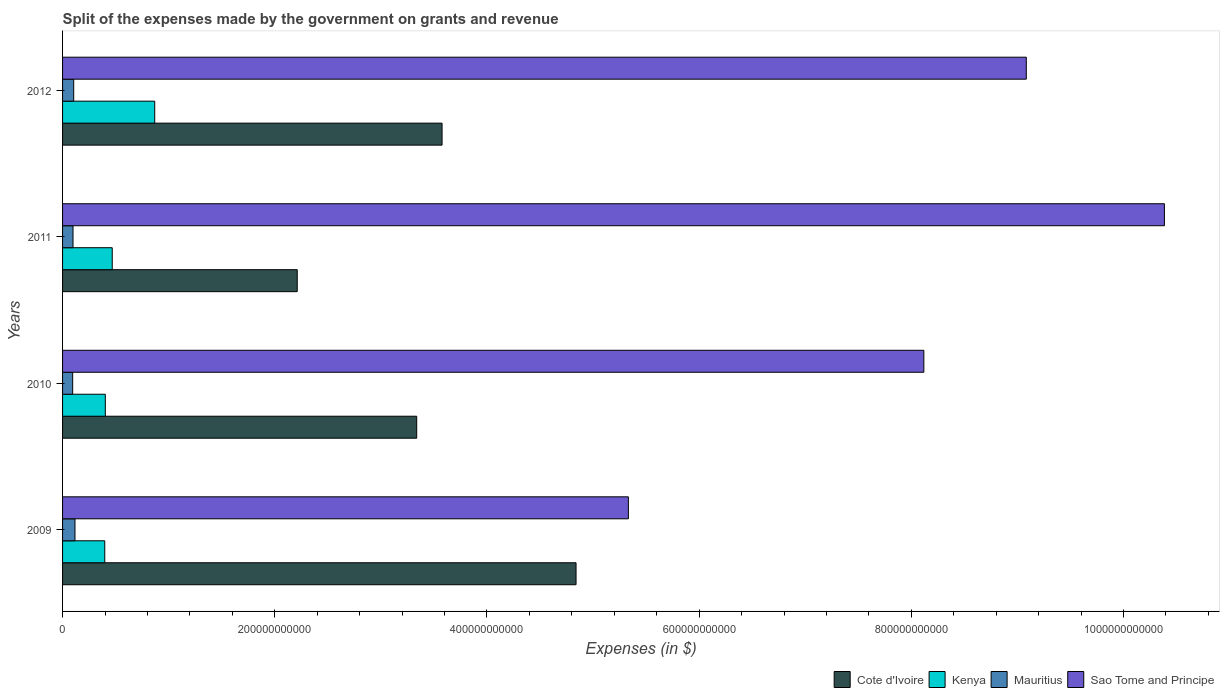Are the number of bars per tick equal to the number of legend labels?
Your answer should be compact. Yes. Are the number of bars on each tick of the Y-axis equal?
Provide a succinct answer. Yes. What is the label of the 4th group of bars from the top?
Make the answer very short. 2009. In how many cases, is the number of bars for a given year not equal to the number of legend labels?
Give a very brief answer. 0. What is the expenses made by the government on grants and revenue in Cote d'Ivoire in 2009?
Provide a succinct answer. 4.84e+11. Across all years, what is the maximum expenses made by the government on grants and revenue in Sao Tome and Principe?
Make the answer very short. 1.04e+12. Across all years, what is the minimum expenses made by the government on grants and revenue in Mauritius?
Your answer should be compact. 9.53e+09. In which year was the expenses made by the government on grants and revenue in Cote d'Ivoire maximum?
Ensure brevity in your answer.  2009. In which year was the expenses made by the government on grants and revenue in Sao Tome and Principe minimum?
Provide a short and direct response. 2009. What is the total expenses made by the government on grants and revenue in Sao Tome and Principe in the graph?
Ensure brevity in your answer.  3.29e+12. What is the difference between the expenses made by the government on grants and revenue in Mauritius in 2010 and that in 2012?
Keep it short and to the point. -9.74e+08. What is the difference between the expenses made by the government on grants and revenue in Sao Tome and Principe in 2011 and the expenses made by the government on grants and revenue in Kenya in 2012?
Give a very brief answer. 9.52e+11. What is the average expenses made by the government on grants and revenue in Mauritius per year?
Provide a short and direct response. 1.04e+1. In the year 2012, what is the difference between the expenses made by the government on grants and revenue in Kenya and expenses made by the government on grants and revenue in Sao Tome and Principe?
Give a very brief answer. -8.21e+11. What is the ratio of the expenses made by the government on grants and revenue in Kenya in 2009 to that in 2010?
Provide a succinct answer. 0.99. Is the expenses made by the government on grants and revenue in Cote d'Ivoire in 2010 less than that in 2012?
Give a very brief answer. Yes. What is the difference between the highest and the second highest expenses made by the government on grants and revenue in Sao Tome and Principe?
Ensure brevity in your answer.  1.30e+11. What is the difference between the highest and the lowest expenses made by the government on grants and revenue in Sao Tome and Principe?
Offer a terse response. 5.05e+11. In how many years, is the expenses made by the government on grants and revenue in Sao Tome and Principe greater than the average expenses made by the government on grants and revenue in Sao Tome and Principe taken over all years?
Your response must be concise. 2. Is the sum of the expenses made by the government on grants and revenue in Cote d'Ivoire in 2009 and 2012 greater than the maximum expenses made by the government on grants and revenue in Kenya across all years?
Provide a short and direct response. Yes. What does the 1st bar from the top in 2009 represents?
Ensure brevity in your answer.  Sao Tome and Principe. What does the 2nd bar from the bottom in 2012 represents?
Your answer should be compact. Kenya. Is it the case that in every year, the sum of the expenses made by the government on grants and revenue in Kenya and expenses made by the government on grants and revenue in Sao Tome and Principe is greater than the expenses made by the government on grants and revenue in Cote d'Ivoire?
Offer a terse response. Yes. How many bars are there?
Your answer should be very brief. 16. How many years are there in the graph?
Ensure brevity in your answer.  4. What is the difference between two consecutive major ticks on the X-axis?
Your answer should be compact. 2.00e+11. Does the graph contain any zero values?
Provide a short and direct response. No. Does the graph contain grids?
Give a very brief answer. No. How many legend labels are there?
Ensure brevity in your answer.  4. What is the title of the graph?
Provide a succinct answer. Split of the expenses made by the government on grants and revenue. Does "Finland" appear as one of the legend labels in the graph?
Provide a short and direct response. No. What is the label or title of the X-axis?
Keep it short and to the point. Expenses (in $). What is the Expenses (in $) of Cote d'Ivoire in 2009?
Provide a short and direct response. 4.84e+11. What is the Expenses (in $) of Kenya in 2009?
Your response must be concise. 3.98e+1. What is the Expenses (in $) in Mauritius in 2009?
Keep it short and to the point. 1.17e+1. What is the Expenses (in $) in Sao Tome and Principe in 2009?
Your answer should be very brief. 5.33e+11. What is the Expenses (in $) in Cote d'Ivoire in 2010?
Your response must be concise. 3.34e+11. What is the Expenses (in $) of Kenya in 2010?
Your answer should be compact. 4.03e+1. What is the Expenses (in $) of Mauritius in 2010?
Your answer should be compact. 9.53e+09. What is the Expenses (in $) of Sao Tome and Principe in 2010?
Your answer should be very brief. 8.12e+11. What is the Expenses (in $) in Cote d'Ivoire in 2011?
Offer a very short reply. 2.21e+11. What is the Expenses (in $) in Kenya in 2011?
Your answer should be compact. 4.68e+1. What is the Expenses (in $) of Mauritius in 2011?
Offer a very short reply. 9.85e+09. What is the Expenses (in $) in Sao Tome and Principe in 2011?
Give a very brief answer. 1.04e+12. What is the Expenses (in $) of Cote d'Ivoire in 2012?
Your answer should be very brief. 3.58e+11. What is the Expenses (in $) of Kenya in 2012?
Make the answer very short. 8.69e+1. What is the Expenses (in $) in Mauritius in 2012?
Keep it short and to the point. 1.05e+1. What is the Expenses (in $) of Sao Tome and Principe in 2012?
Make the answer very short. 9.08e+11. Across all years, what is the maximum Expenses (in $) of Cote d'Ivoire?
Your response must be concise. 4.84e+11. Across all years, what is the maximum Expenses (in $) of Kenya?
Keep it short and to the point. 8.69e+1. Across all years, what is the maximum Expenses (in $) of Mauritius?
Your response must be concise. 1.17e+1. Across all years, what is the maximum Expenses (in $) of Sao Tome and Principe?
Keep it short and to the point. 1.04e+12. Across all years, what is the minimum Expenses (in $) of Cote d'Ivoire?
Provide a succinct answer. 2.21e+11. Across all years, what is the minimum Expenses (in $) in Kenya?
Provide a short and direct response. 3.98e+1. Across all years, what is the minimum Expenses (in $) of Mauritius?
Offer a very short reply. 9.53e+09. Across all years, what is the minimum Expenses (in $) of Sao Tome and Principe?
Ensure brevity in your answer.  5.33e+11. What is the total Expenses (in $) in Cote d'Ivoire in the graph?
Provide a succinct answer. 1.40e+12. What is the total Expenses (in $) of Kenya in the graph?
Keep it short and to the point. 2.14e+11. What is the total Expenses (in $) in Mauritius in the graph?
Your answer should be very brief. 4.16e+1. What is the total Expenses (in $) of Sao Tome and Principe in the graph?
Provide a succinct answer. 3.29e+12. What is the difference between the Expenses (in $) of Cote d'Ivoire in 2009 and that in 2010?
Keep it short and to the point. 1.50e+11. What is the difference between the Expenses (in $) of Kenya in 2009 and that in 2010?
Make the answer very short. -5.18e+08. What is the difference between the Expenses (in $) of Mauritius in 2009 and that in 2010?
Ensure brevity in your answer.  2.17e+09. What is the difference between the Expenses (in $) in Sao Tome and Principe in 2009 and that in 2010?
Provide a succinct answer. -2.78e+11. What is the difference between the Expenses (in $) of Cote d'Ivoire in 2009 and that in 2011?
Keep it short and to the point. 2.63e+11. What is the difference between the Expenses (in $) of Kenya in 2009 and that in 2011?
Make the answer very short. -7.04e+09. What is the difference between the Expenses (in $) of Mauritius in 2009 and that in 2011?
Make the answer very short. 1.84e+09. What is the difference between the Expenses (in $) in Sao Tome and Principe in 2009 and that in 2011?
Your answer should be very brief. -5.05e+11. What is the difference between the Expenses (in $) of Cote d'Ivoire in 2009 and that in 2012?
Offer a very short reply. 1.26e+11. What is the difference between the Expenses (in $) in Kenya in 2009 and that in 2012?
Your answer should be compact. -4.71e+1. What is the difference between the Expenses (in $) of Mauritius in 2009 and that in 2012?
Offer a terse response. 1.20e+09. What is the difference between the Expenses (in $) of Sao Tome and Principe in 2009 and that in 2012?
Your answer should be very brief. -3.75e+11. What is the difference between the Expenses (in $) in Cote d'Ivoire in 2010 and that in 2011?
Your answer should be very brief. 1.13e+11. What is the difference between the Expenses (in $) of Kenya in 2010 and that in 2011?
Ensure brevity in your answer.  -6.52e+09. What is the difference between the Expenses (in $) of Mauritius in 2010 and that in 2011?
Provide a succinct answer. -3.28e+08. What is the difference between the Expenses (in $) in Sao Tome and Principe in 2010 and that in 2011?
Ensure brevity in your answer.  -2.27e+11. What is the difference between the Expenses (in $) in Cote d'Ivoire in 2010 and that in 2012?
Your answer should be very brief. -2.39e+1. What is the difference between the Expenses (in $) in Kenya in 2010 and that in 2012?
Provide a short and direct response. -4.66e+1. What is the difference between the Expenses (in $) in Mauritius in 2010 and that in 2012?
Make the answer very short. -9.74e+08. What is the difference between the Expenses (in $) of Sao Tome and Principe in 2010 and that in 2012?
Your answer should be very brief. -9.66e+1. What is the difference between the Expenses (in $) of Cote d'Ivoire in 2011 and that in 2012?
Make the answer very short. -1.37e+11. What is the difference between the Expenses (in $) of Kenya in 2011 and that in 2012?
Provide a short and direct response. -4.00e+1. What is the difference between the Expenses (in $) in Mauritius in 2011 and that in 2012?
Your answer should be compact. -6.46e+08. What is the difference between the Expenses (in $) in Sao Tome and Principe in 2011 and that in 2012?
Your answer should be very brief. 1.30e+11. What is the difference between the Expenses (in $) of Cote d'Ivoire in 2009 and the Expenses (in $) of Kenya in 2010?
Your response must be concise. 4.44e+11. What is the difference between the Expenses (in $) of Cote d'Ivoire in 2009 and the Expenses (in $) of Mauritius in 2010?
Your answer should be very brief. 4.74e+11. What is the difference between the Expenses (in $) in Cote d'Ivoire in 2009 and the Expenses (in $) in Sao Tome and Principe in 2010?
Your answer should be very brief. -3.28e+11. What is the difference between the Expenses (in $) in Kenya in 2009 and the Expenses (in $) in Mauritius in 2010?
Your answer should be very brief. 3.02e+1. What is the difference between the Expenses (in $) in Kenya in 2009 and the Expenses (in $) in Sao Tome and Principe in 2010?
Make the answer very short. -7.72e+11. What is the difference between the Expenses (in $) of Mauritius in 2009 and the Expenses (in $) of Sao Tome and Principe in 2010?
Offer a very short reply. -8.00e+11. What is the difference between the Expenses (in $) of Cote d'Ivoire in 2009 and the Expenses (in $) of Kenya in 2011?
Ensure brevity in your answer.  4.37e+11. What is the difference between the Expenses (in $) in Cote d'Ivoire in 2009 and the Expenses (in $) in Mauritius in 2011?
Keep it short and to the point. 4.74e+11. What is the difference between the Expenses (in $) of Cote d'Ivoire in 2009 and the Expenses (in $) of Sao Tome and Principe in 2011?
Offer a very short reply. -5.55e+11. What is the difference between the Expenses (in $) of Kenya in 2009 and the Expenses (in $) of Mauritius in 2011?
Offer a terse response. 2.99e+1. What is the difference between the Expenses (in $) of Kenya in 2009 and the Expenses (in $) of Sao Tome and Principe in 2011?
Your response must be concise. -9.99e+11. What is the difference between the Expenses (in $) of Mauritius in 2009 and the Expenses (in $) of Sao Tome and Principe in 2011?
Your response must be concise. -1.03e+12. What is the difference between the Expenses (in $) in Cote d'Ivoire in 2009 and the Expenses (in $) in Kenya in 2012?
Make the answer very short. 3.97e+11. What is the difference between the Expenses (in $) in Cote d'Ivoire in 2009 and the Expenses (in $) in Mauritius in 2012?
Make the answer very short. 4.73e+11. What is the difference between the Expenses (in $) in Cote d'Ivoire in 2009 and the Expenses (in $) in Sao Tome and Principe in 2012?
Ensure brevity in your answer.  -4.24e+11. What is the difference between the Expenses (in $) of Kenya in 2009 and the Expenses (in $) of Mauritius in 2012?
Keep it short and to the point. 2.93e+1. What is the difference between the Expenses (in $) in Kenya in 2009 and the Expenses (in $) in Sao Tome and Principe in 2012?
Your answer should be very brief. -8.69e+11. What is the difference between the Expenses (in $) of Mauritius in 2009 and the Expenses (in $) of Sao Tome and Principe in 2012?
Your answer should be compact. -8.97e+11. What is the difference between the Expenses (in $) in Cote d'Ivoire in 2010 and the Expenses (in $) in Kenya in 2011?
Give a very brief answer. 2.87e+11. What is the difference between the Expenses (in $) in Cote d'Ivoire in 2010 and the Expenses (in $) in Mauritius in 2011?
Offer a terse response. 3.24e+11. What is the difference between the Expenses (in $) in Cote d'Ivoire in 2010 and the Expenses (in $) in Sao Tome and Principe in 2011?
Offer a terse response. -7.05e+11. What is the difference between the Expenses (in $) in Kenya in 2010 and the Expenses (in $) in Mauritius in 2011?
Offer a terse response. 3.04e+1. What is the difference between the Expenses (in $) of Kenya in 2010 and the Expenses (in $) of Sao Tome and Principe in 2011?
Make the answer very short. -9.98e+11. What is the difference between the Expenses (in $) in Mauritius in 2010 and the Expenses (in $) in Sao Tome and Principe in 2011?
Provide a succinct answer. -1.03e+12. What is the difference between the Expenses (in $) in Cote d'Ivoire in 2010 and the Expenses (in $) in Kenya in 2012?
Ensure brevity in your answer.  2.47e+11. What is the difference between the Expenses (in $) in Cote d'Ivoire in 2010 and the Expenses (in $) in Mauritius in 2012?
Provide a succinct answer. 3.23e+11. What is the difference between the Expenses (in $) in Cote d'Ivoire in 2010 and the Expenses (in $) in Sao Tome and Principe in 2012?
Make the answer very short. -5.75e+11. What is the difference between the Expenses (in $) in Kenya in 2010 and the Expenses (in $) in Mauritius in 2012?
Your answer should be very brief. 2.98e+1. What is the difference between the Expenses (in $) of Kenya in 2010 and the Expenses (in $) of Sao Tome and Principe in 2012?
Offer a very short reply. -8.68e+11. What is the difference between the Expenses (in $) of Mauritius in 2010 and the Expenses (in $) of Sao Tome and Principe in 2012?
Provide a short and direct response. -8.99e+11. What is the difference between the Expenses (in $) in Cote d'Ivoire in 2011 and the Expenses (in $) in Kenya in 2012?
Keep it short and to the point. 1.34e+11. What is the difference between the Expenses (in $) in Cote d'Ivoire in 2011 and the Expenses (in $) in Mauritius in 2012?
Offer a very short reply. 2.11e+11. What is the difference between the Expenses (in $) of Cote d'Ivoire in 2011 and the Expenses (in $) of Sao Tome and Principe in 2012?
Make the answer very short. -6.87e+11. What is the difference between the Expenses (in $) in Kenya in 2011 and the Expenses (in $) in Mauritius in 2012?
Your answer should be very brief. 3.63e+1. What is the difference between the Expenses (in $) in Kenya in 2011 and the Expenses (in $) in Sao Tome and Principe in 2012?
Offer a very short reply. -8.62e+11. What is the difference between the Expenses (in $) in Mauritius in 2011 and the Expenses (in $) in Sao Tome and Principe in 2012?
Give a very brief answer. -8.98e+11. What is the average Expenses (in $) in Cote d'Ivoire per year?
Ensure brevity in your answer.  3.49e+11. What is the average Expenses (in $) of Kenya per year?
Make the answer very short. 5.34e+1. What is the average Expenses (in $) of Mauritius per year?
Give a very brief answer. 1.04e+1. What is the average Expenses (in $) in Sao Tome and Principe per year?
Your response must be concise. 8.23e+11. In the year 2009, what is the difference between the Expenses (in $) in Cote d'Ivoire and Expenses (in $) in Kenya?
Your answer should be very brief. 4.44e+11. In the year 2009, what is the difference between the Expenses (in $) in Cote d'Ivoire and Expenses (in $) in Mauritius?
Offer a terse response. 4.72e+11. In the year 2009, what is the difference between the Expenses (in $) of Cote d'Ivoire and Expenses (in $) of Sao Tome and Principe?
Your response must be concise. -4.93e+1. In the year 2009, what is the difference between the Expenses (in $) of Kenya and Expenses (in $) of Mauritius?
Make the answer very short. 2.81e+1. In the year 2009, what is the difference between the Expenses (in $) of Kenya and Expenses (in $) of Sao Tome and Principe?
Ensure brevity in your answer.  -4.94e+11. In the year 2009, what is the difference between the Expenses (in $) in Mauritius and Expenses (in $) in Sao Tome and Principe?
Provide a succinct answer. -5.22e+11. In the year 2010, what is the difference between the Expenses (in $) of Cote d'Ivoire and Expenses (in $) of Kenya?
Your answer should be compact. 2.93e+11. In the year 2010, what is the difference between the Expenses (in $) of Cote d'Ivoire and Expenses (in $) of Mauritius?
Your answer should be compact. 3.24e+11. In the year 2010, what is the difference between the Expenses (in $) in Cote d'Ivoire and Expenses (in $) in Sao Tome and Principe?
Your response must be concise. -4.78e+11. In the year 2010, what is the difference between the Expenses (in $) in Kenya and Expenses (in $) in Mauritius?
Your response must be concise. 3.08e+1. In the year 2010, what is the difference between the Expenses (in $) of Kenya and Expenses (in $) of Sao Tome and Principe?
Ensure brevity in your answer.  -7.71e+11. In the year 2010, what is the difference between the Expenses (in $) of Mauritius and Expenses (in $) of Sao Tome and Principe?
Your response must be concise. -8.02e+11. In the year 2011, what is the difference between the Expenses (in $) in Cote d'Ivoire and Expenses (in $) in Kenya?
Keep it short and to the point. 1.74e+11. In the year 2011, what is the difference between the Expenses (in $) in Cote d'Ivoire and Expenses (in $) in Mauritius?
Give a very brief answer. 2.11e+11. In the year 2011, what is the difference between the Expenses (in $) of Cote d'Ivoire and Expenses (in $) of Sao Tome and Principe?
Your response must be concise. -8.17e+11. In the year 2011, what is the difference between the Expenses (in $) in Kenya and Expenses (in $) in Mauritius?
Offer a very short reply. 3.70e+1. In the year 2011, what is the difference between the Expenses (in $) of Kenya and Expenses (in $) of Sao Tome and Principe?
Make the answer very short. -9.92e+11. In the year 2011, what is the difference between the Expenses (in $) in Mauritius and Expenses (in $) in Sao Tome and Principe?
Offer a very short reply. -1.03e+12. In the year 2012, what is the difference between the Expenses (in $) in Cote d'Ivoire and Expenses (in $) in Kenya?
Provide a short and direct response. 2.71e+11. In the year 2012, what is the difference between the Expenses (in $) in Cote d'Ivoire and Expenses (in $) in Mauritius?
Ensure brevity in your answer.  3.47e+11. In the year 2012, what is the difference between the Expenses (in $) in Cote d'Ivoire and Expenses (in $) in Sao Tome and Principe?
Give a very brief answer. -5.51e+11. In the year 2012, what is the difference between the Expenses (in $) in Kenya and Expenses (in $) in Mauritius?
Keep it short and to the point. 7.64e+1. In the year 2012, what is the difference between the Expenses (in $) in Kenya and Expenses (in $) in Sao Tome and Principe?
Provide a short and direct response. -8.21e+11. In the year 2012, what is the difference between the Expenses (in $) in Mauritius and Expenses (in $) in Sao Tome and Principe?
Give a very brief answer. -8.98e+11. What is the ratio of the Expenses (in $) of Cote d'Ivoire in 2009 to that in 2010?
Your answer should be compact. 1.45. What is the ratio of the Expenses (in $) in Kenya in 2009 to that in 2010?
Offer a terse response. 0.99. What is the ratio of the Expenses (in $) in Mauritius in 2009 to that in 2010?
Give a very brief answer. 1.23. What is the ratio of the Expenses (in $) of Sao Tome and Principe in 2009 to that in 2010?
Your answer should be very brief. 0.66. What is the ratio of the Expenses (in $) of Cote d'Ivoire in 2009 to that in 2011?
Offer a very short reply. 2.19. What is the ratio of the Expenses (in $) of Kenya in 2009 to that in 2011?
Keep it short and to the point. 0.85. What is the ratio of the Expenses (in $) of Mauritius in 2009 to that in 2011?
Make the answer very short. 1.19. What is the ratio of the Expenses (in $) in Sao Tome and Principe in 2009 to that in 2011?
Your answer should be compact. 0.51. What is the ratio of the Expenses (in $) in Cote d'Ivoire in 2009 to that in 2012?
Your answer should be very brief. 1.35. What is the ratio of the Expenses (in $) in Kenya in 2009 to that in 2012?
Provide a succinct answer. 0.46. What is the ratio of the Expenses (in $) of Mauritius in 2009 to that in 2012?
Offer a very short reply. 1.11. What is the ratio of the Expenses (in $) of Sao Tome and Principe in 2009 to that in 2012?
Offer a very short reply. 0.59. What is the ratio of the Expenses (in $) in Cote d'Ivoire in 2010 to that in 2011?
Offer a very short reply. 1.51. What is the ratio of the Expenses (in $) of Kenya in 2010 to that in 2011?
Offer a terse response. 0.86. What is the ratio of the Expenses (in $) in Mauritius in 2010 to that in 2011?
Offer a terse response. 0.97. What is the ratio of the Expenses (in $) in Sao Tome and Principe in 2010 to that in 2011?
Your answer should be compact. 0.78. What is the ratio of the Expenses (in $) in Cote d'Ivoire in 2010 to that in 2012?
Provide a short and direct response. 0.93. What is the ratio of the Expenses (in $) in Kenya in 2010 to that in 2012?
Provide a short and direct response. 0.46. What is the ratio of the Expenses (in $) in Mauritius in 2010 to that in 2012?
Your answer should be compact. 0.91. What is the ratio of the Expenses (in $) in Sao Tome and Principe in 2010 to that in 2012?
Give a very brief answer. 0.89. What is the ratio of the Expenses (in $) of Cote d'Ivoire in 2011 to that in 2012?
Offer a terse response. 0.62. What is the ratio of the Expenses (in $) of Kenya in 2011 to that in 2012?
Your response must be concise. 0.54. What is the ratio of the Expenses (in $) of Mauritius in 2011 to that in 2012?
Provide a succinct answer. 0.94. What is the ratio of the Expenses (in $) in Sao Tome and Principe in 2011 to that in 2012?
Make the answer very short. 1.14. What is the difference between the highest and the second highest Expenses (in $) of Cote d'Ivoire?
Your response must be concise. 1.26e+11. What is the difference between the highest and the second highest Expenses (in $) of Kenya?
Your answer should be compact. 4.00e+1. What is the difference between the highest and the second highest Expenses (in $) of Mauritius?
Ensure brevity in your answer.  1.20e+09. What is the difference between the highest and the second highest Expenses (in $) of Sao Tome and Principe?
Give a very brief answer. 1.30e+11. What is the difference between the highest and the lowest Expenses (in $) of Cote d'Ivoire?
Provide a short and direct response. 2.63e+11. What is the difference between the highest and the lowest Expenses (in $) of Kenya?
Ensure brevity in your answer.  4.71e+1. What is the difference between the highest and the lowest Expenses (in $) of Mauritius?
Your answer should be compact. 2.17e+09. What is the difference between the highest and the lowest Expenses (in $) of Sao Tome and Principe?
Give a very brief answer. 5.05e+11. 